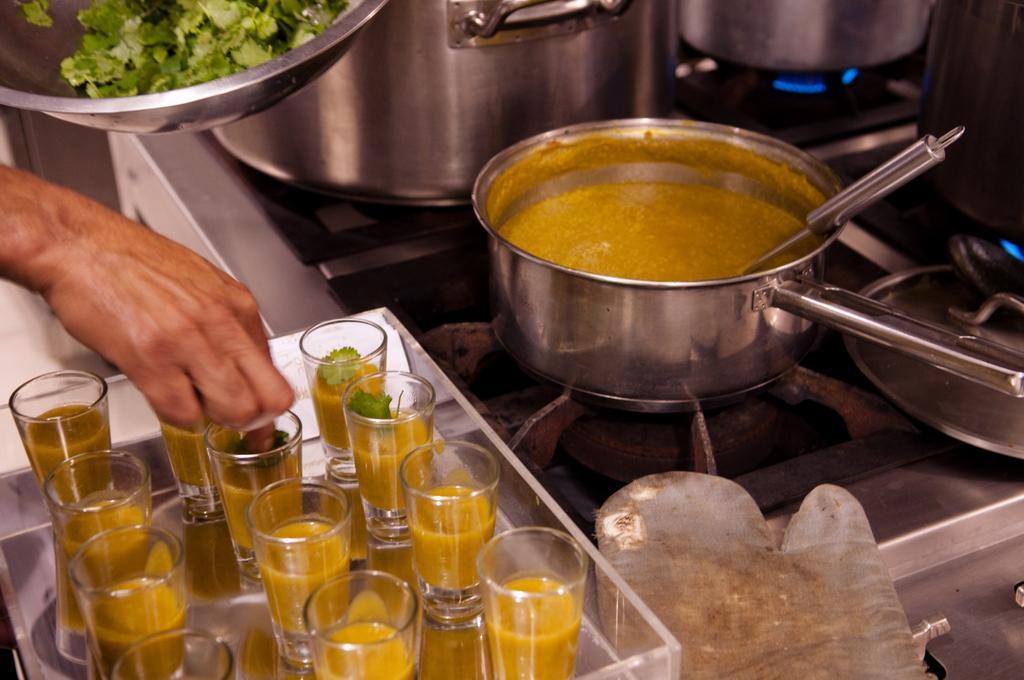Please provide a concise description of this image. In this picture I can see few glasses in front and they're on a tray and aside to this tray I see a glove. In this middle of this picture I see a gas stove, on which there are few utensils and on the left side of this image I see a person's hand and on the top of the hand I see a utensil in which there are coriander leaves. 